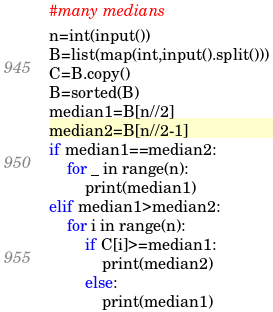<code> <loc_0><loc_0><loc_500><loc_500><_Python_>#many medians
n=int(input())
B=list(map(int,input().split()))
C=B.copy()
B=sorted(B)
median1=B[n//2]
median2=B[n//2-1]
if median1==median2:
    for _ in range(n):
        print(median1)
elif median1>median2:
    for i in range(n):
        if C[i]>=median1:
            print(median2)
        else:
            print(median1)</code> 